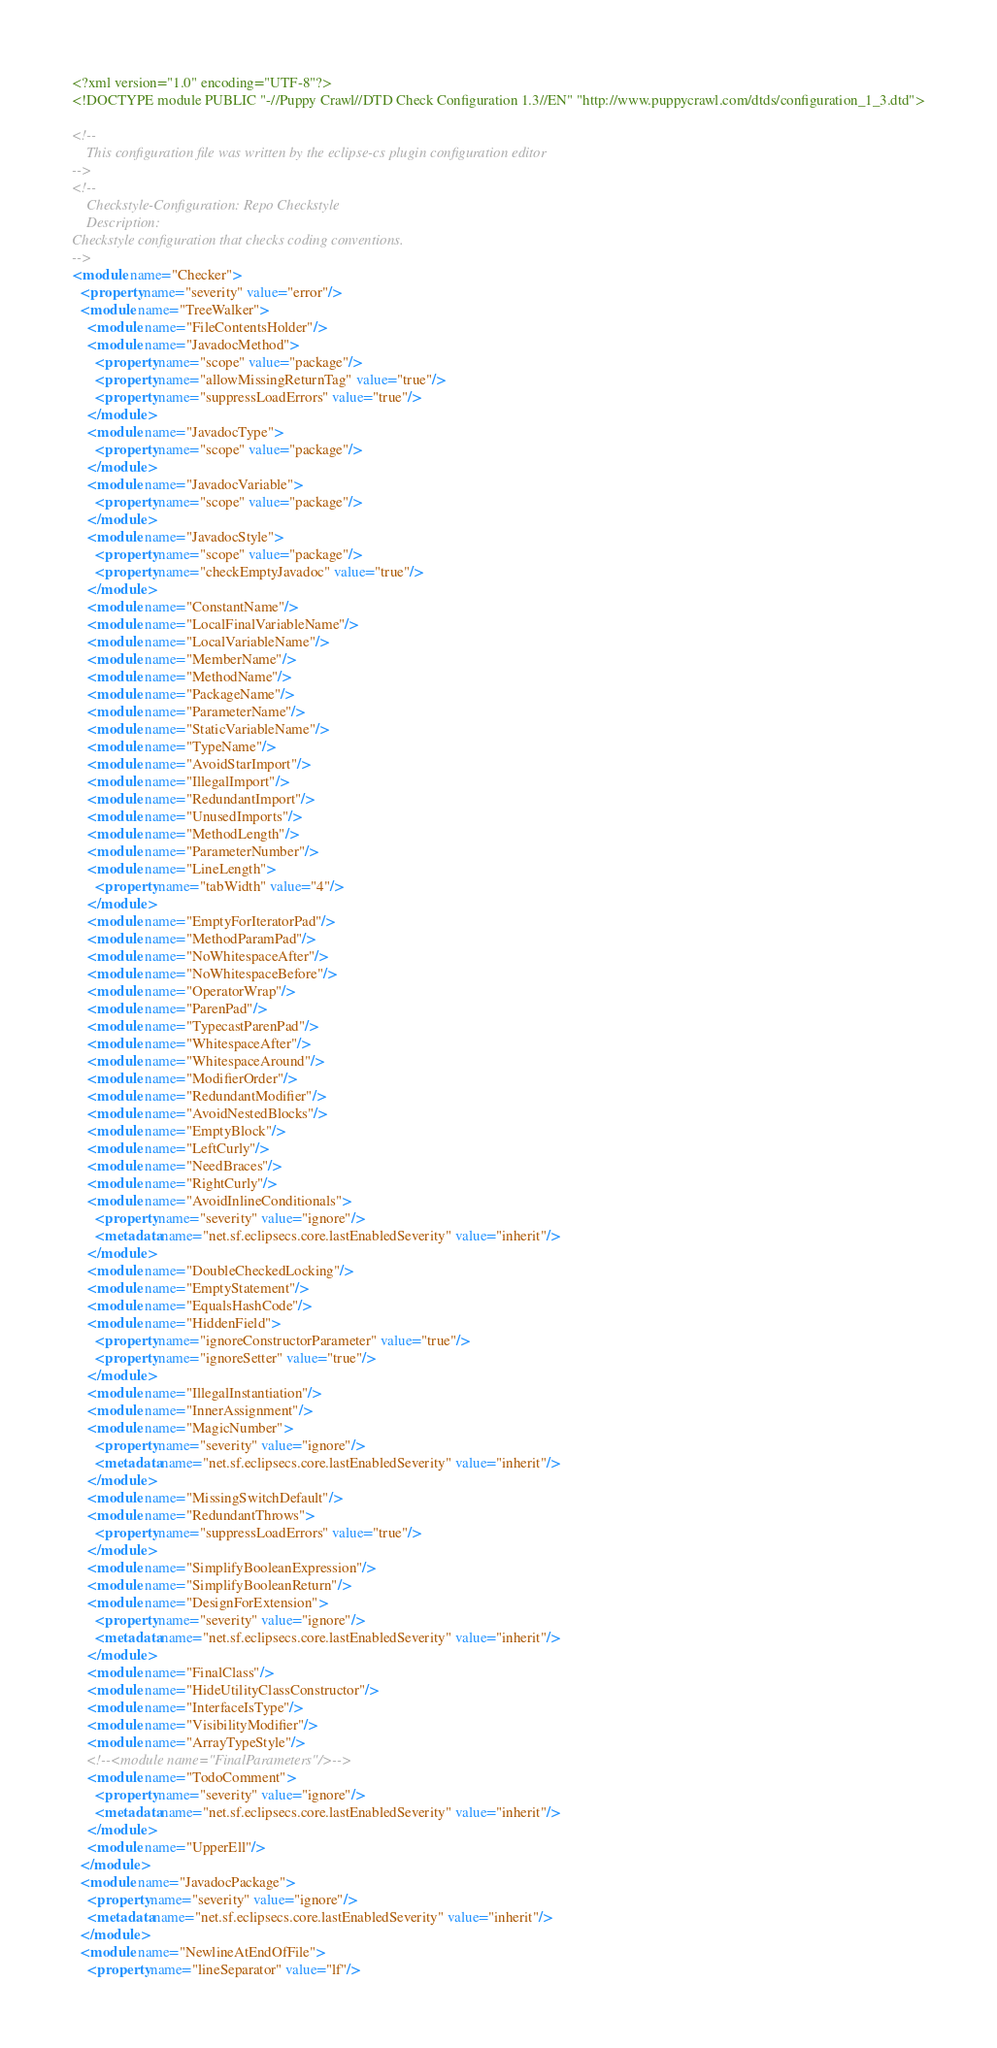<code> <loc_0><loc_0><loc_500><loc_500><_XML_><?xml version="1.0" encoding="UTF-8"?>
<!DOCTYPE module PUBLIC "-//Puppy Crawl//DTD Check Configuration 1.3//EN" "http://www.puppycrawl.com/dtds/configuration_1_3.dtd">

<!--
    This configuration file was written by the eclipse-cs plugin configuration editor
-->
<!--
    Checkstyle-Configuration: Repo Checkstyle
    Description: 
Checkstyle configuration that checks coding conventions.
-->
<module name="Checker">
  <property name="severity" value="error"/>
  <module name="TreeWalker">
    <module name="FileContentsHolder"/>
    <module name="JavadocMethod">
      <property name="scope" value="package"/>
      <property name="allowMissingReturnTag" value="true"/>
      <property name="suppressLoadErrors" value="true"/>
    </module>
    <module name="JavadocType">
      <property name="scope" value="package"/>
    </module>
    <module name="JavadocVariable">
      <property name="scope" value="package"/>
    </module>
    <module name="JavadocStyle">
      <property name="scope" value="package"/>
      <property name="checkEmptyJavadoc" value="true"/>
    </module>
    <module name="ConstantName"/>
    <module name="LocalFinalVariableName"/>
    <module name="LocalVariableName"/>
    <module name="MemberName"/>
    <module name="MethodName"/>
    <module name="PackageName"/>
    <module name="ParameterName"/>
    <module name="StaticVariableName"/>
    <module name="TypeName"/>
    <module name="AvoidStarImport"/>
    <module name="IllegalImport"/>
    <module name="RedundantImport"/>
    <module name="UnusedImports"/>
    <module name="MethodLength"/>
    <module name="ParameterNumber"/>
    <module name="LineLength">
      <property name="tabWidth" value="4"/>
    </module>
    <module name="EmptyForIteratorPad"/>
    <module name="MethodParamPad"/>
    <module name="NoWhitespaceAfter"/>
    <module name="NoWhitespaceBefore"/>
    <module name="OperatorWrap"/>
    <module name="ParenPad"/>
    <module name="TypecastParenPad"/>
    <module name="WhitespaceAfter"/>
    <module name="WhitespaceAround"/>
    <module name="ModifierOrder"/>
    <module name="RedundantModifier"/>
    <module name="AvoidNestedBlocks"/>
    <module name="EmptyBlock"/>
    <module name="LeftCurly"/>
    <module name="NeedBraces"/>
    <module name="RightCurly"/>
    <module name="AvoidInlineConditionals">
      <property name="severity" value="ignore"/>
      <metadata name="net.sf.eclipsecs.core.lastEnabledSeverity" value="inherit"/>
    </module>
    <module name="DoubleCheckedLocking"/>
    <module name="EmptyStatement"/>
    <module name="EqualsHashCode"/>
    <module name="HiddenField">
      <property name="ignoreConstructorParameter" value="true"/>
      <property name="ignoreSetter" value="true"/>
    </module>
    <module name="IllegalInstantiation"/>
    <module name="InnerAssignment"/>
    <module name="MagicNumber">
      <property name="severity" value="ignore"/>
      <metadata name="net.sf.eclipsecs.core.lastEnabledSeverity" value="inherit"/>
    </module>
    <module name="MissingSwitchDefault"/>
    <module name="RedundantThrows">
      <property name="suppressLoadErrors" value="true"/>
    </module>
    <module name="SimplifyBooleanExpression"/>
    <module name="SimplifyBooleanReturn"/>
    <module name="DesignForExtension">
      <property name="severity" value="ignore"/>
      <metadata name="net.sf.eclipsecs.core.lastEnabledSeverity" value="inherit"/>
    </module>
    <module name="FinalClass"/>
    <module name="HideUtilityClassConstructor"/>
    <module name="InterfaceIsType"/>
    <module name="VisibilityModifier"/>
    <module name="ArrayTypeStyle"/>
    <!--<module name="FinalParameters"/>-->
    <module name="TodoComment">
      <property name="severity" value="ignore"/>
      <metadata name="net.sf.eclipsecs.core.lastEnabledSeverity" value="inherit"/>
    </module>
    <module name="UpperEll"/>
  </module>
  <module name="JavadocPackage">
    <property name="severity" value="ignore"/>
    <metadata name="net.sf.eclipsecs.core.lastEnabledSeverity" value="inherit"/>
  </module>
  <module name="NewlineAtEndOfFile">
    <property name="lineSeparator" value="lf"/></code> 